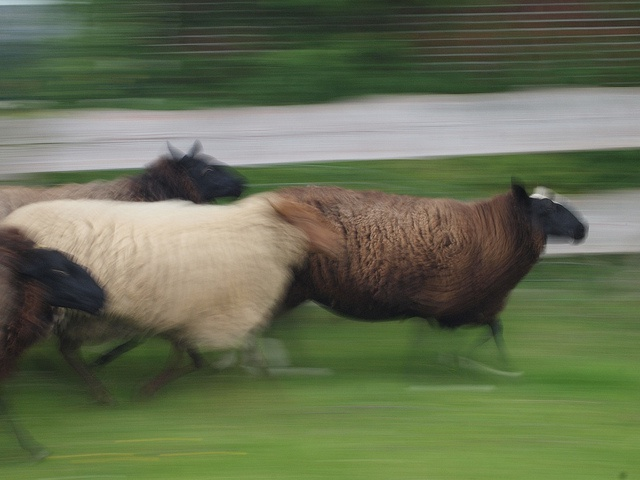Describe the objects in this image and their specific colors. I can see sheep in lightblue, black, gray, and tan tones, sheep in lightblue, black, and gray tones, and sheep in lightblue, black, gray, and darkgray tones in this image. 